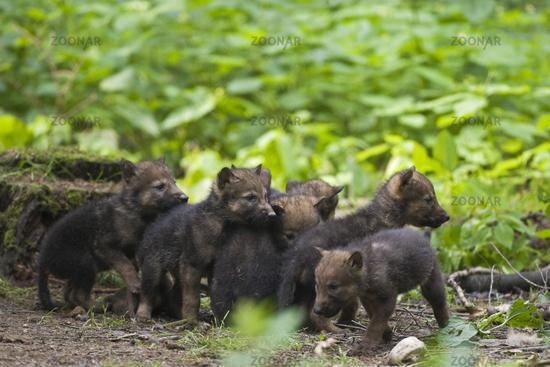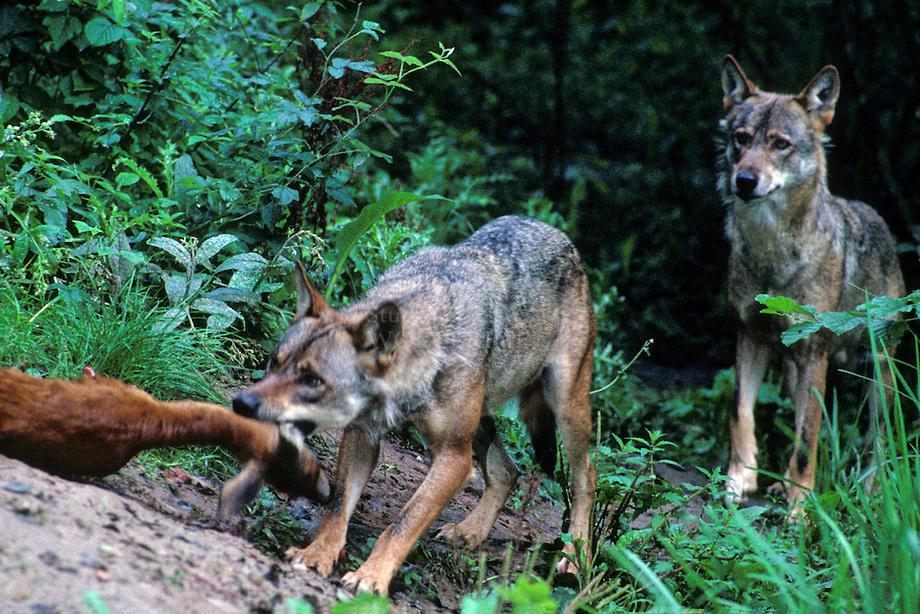The first image is the image on the left, the second image is the image on the right. Considering the images on both sides, is "The left image contains exactly two baby wolves." valid? Answer yes or no. No. The first image is the image on the left, the second image is the image on the right. Evaluate the accuracy of this statement regarding the images: "An image includes a wild dog bending down toward the carcass of an animal.". Is it true? Answer yes or no. Yes. 